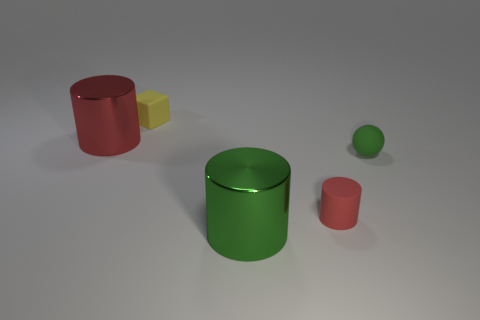Add 1 big yellow metal blocks. How many objects exist? 6 Subtract all balls. How many objects are left? 4 Subtract 0 blue blocks. How many objects are left? 5 Subtract all gray blocks. Subtract all green metal cylinders. How many objects are left? 4 Add 1 red cylinders. How many red cylinders are left? 3 Add 4 tiny blocks. How many tiny blocks exist? 5 